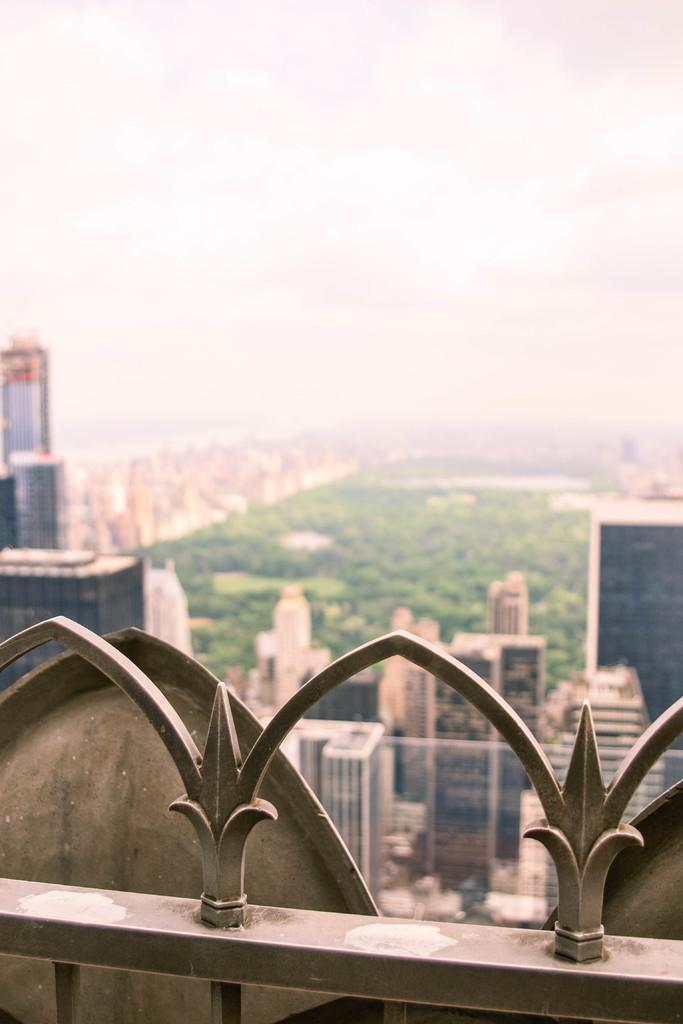What is the primary subject of the image? The primary subject of the image is many buildings. What type of natural elements can be seen in the image? There are trees in the image. What part of the natural environment is visible in the image? The sky is visible in the image. What type of toy can be seen in the jar in the image? There is no toy or jar present in the image. What team is visible in the image? There is no team visible in the image. 